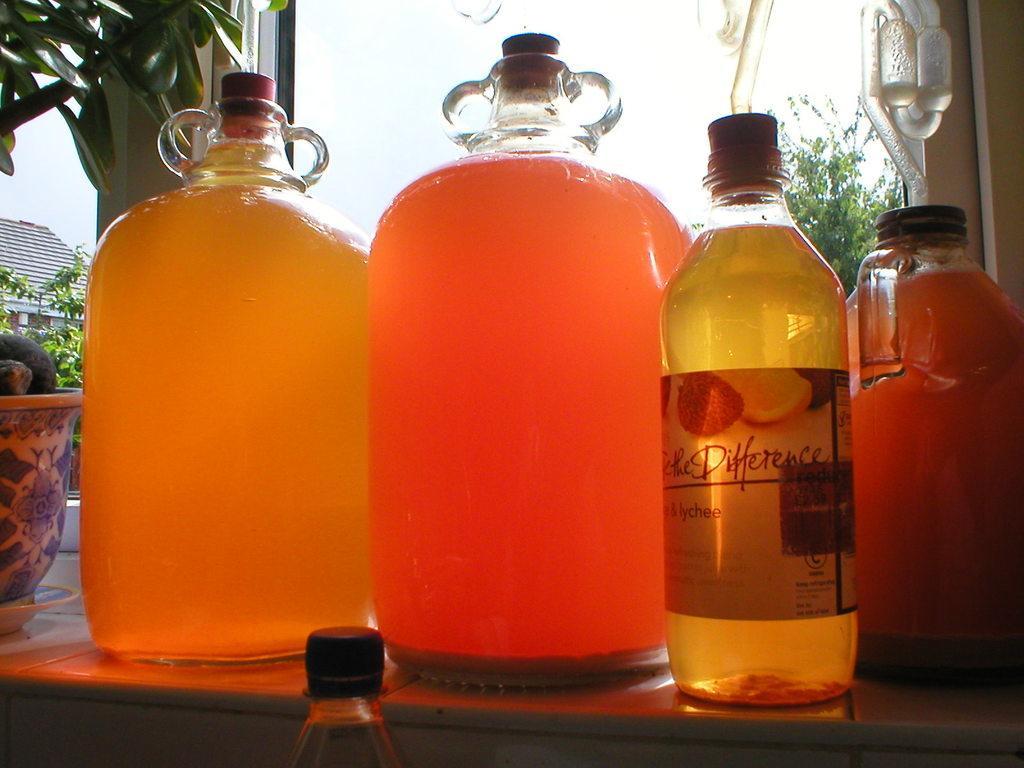Could you give a brief overview of what you see in this image? This picture shows couple of bottles and two glass jars and a house and few trees around 